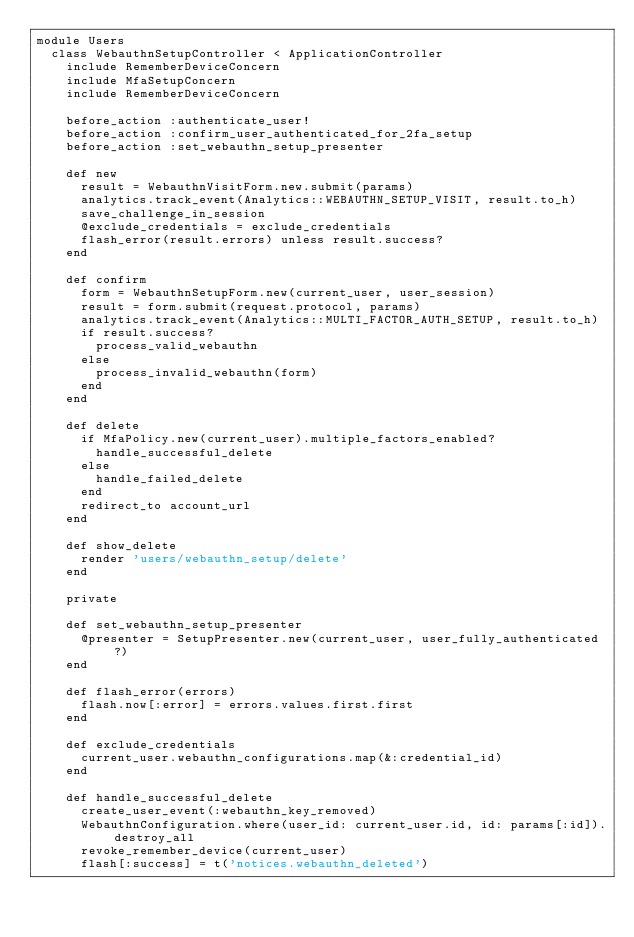Convert code to text. <code><loc_0><loc_0><loc_500><loc_500><_Ruby_>module Users
  class WebauthnSetupController < ApplicationController
    include RememberDeviceConcern
    include MfaSetupConcern
    include RememberDeviceConcern

    before_action :authenticate_user!
    before_action :confirm_user_authenticated_for_2fa_setup
    before_action :set_webauthn_setup_presenter

    def new
      result = WebauthnVisitForm.new.submit(params)
      analytics.track_event(Analytics::WEBAUTHN_SETUP_VISIT, result.to_h)
      save_challenge_in_session
      @exclude_credentials = exclude_credentials
      flash_error(result.errors) unless result.success?
    end

    def confirm
      form = WebauthnSetupForm.new(current_user, user_session)
      result = form.submit(request.protocol, params)
      analytics.track_event(Analytics::MULTI_FACTOR_AUTH_SETUP, result.to_h)
      if result.success?
        process_valid_webauthn
      else
        process_invalid_webauthn(form)
      end
    end

    def delete
      if MfaPolicy.new(current_user).multiple_factors_enabled?
        handle_successful_delete
      else
        handle_failed_delete
      end
      redirect_to account_url
    end

    def show_delete
      render 'users/webauthn_setup/delete'
    end

    private

    def set_webauthn_setup_presenter
      @presenter = SetupPresenter.new(current_user, user_fully_authenticated?)
    end

    def flash_error(errors)
      flash.now[:error] = errors.values.first.first
    end

    def exclude_credentials
      current_user.webauthn_configurations.map(&:credential_id)
    end

    def handle_successful_delete
      create_user_event(:webauthn_key_removed)
      WebauthnConfiguration.where(user_id: current_user.id, id: params[:id]).destroy_all
      revoke_remember_device(current_user)
      flash[:success] = t('notices.webauthn_deleted')</code> 